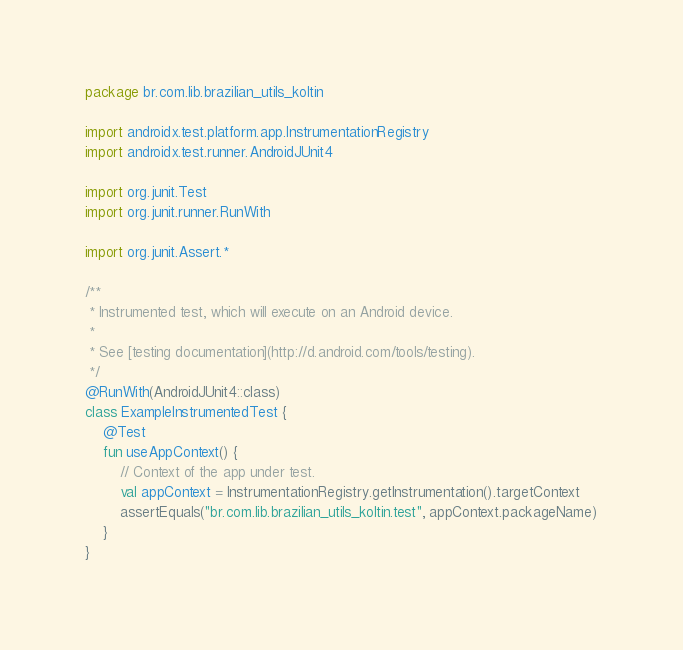<code> <loc_0><loc_0><loc_500><loc_500><_Kotlin_>package br.com.lib.brazilian_utils_koltin

import androidx.test.platform.app.InstrumentationRegistry
import androidx.test.runner.AndroidJUnit4

import org.junit.Test
import org.junit.runner.RunWith

import org.junit.Assert.*

/**
 * Instrumented test, which will execute on an Android device.
 *
 * See [testing documentation](http://d.android.com/tools/testing).
 */
@RunWith(AndroidJUnit4::class)
class ExampleInstrumentedTest {
    @Test
    fun useAppContext() {
        // Context of the app under test.
        val appContext = InstrumentationRegistry.getInstrumentation().targetContext
        assertEquals("br.com.lib.brazilian_utils_koltin.test", appContext.packageName)
    }
}
</code> 